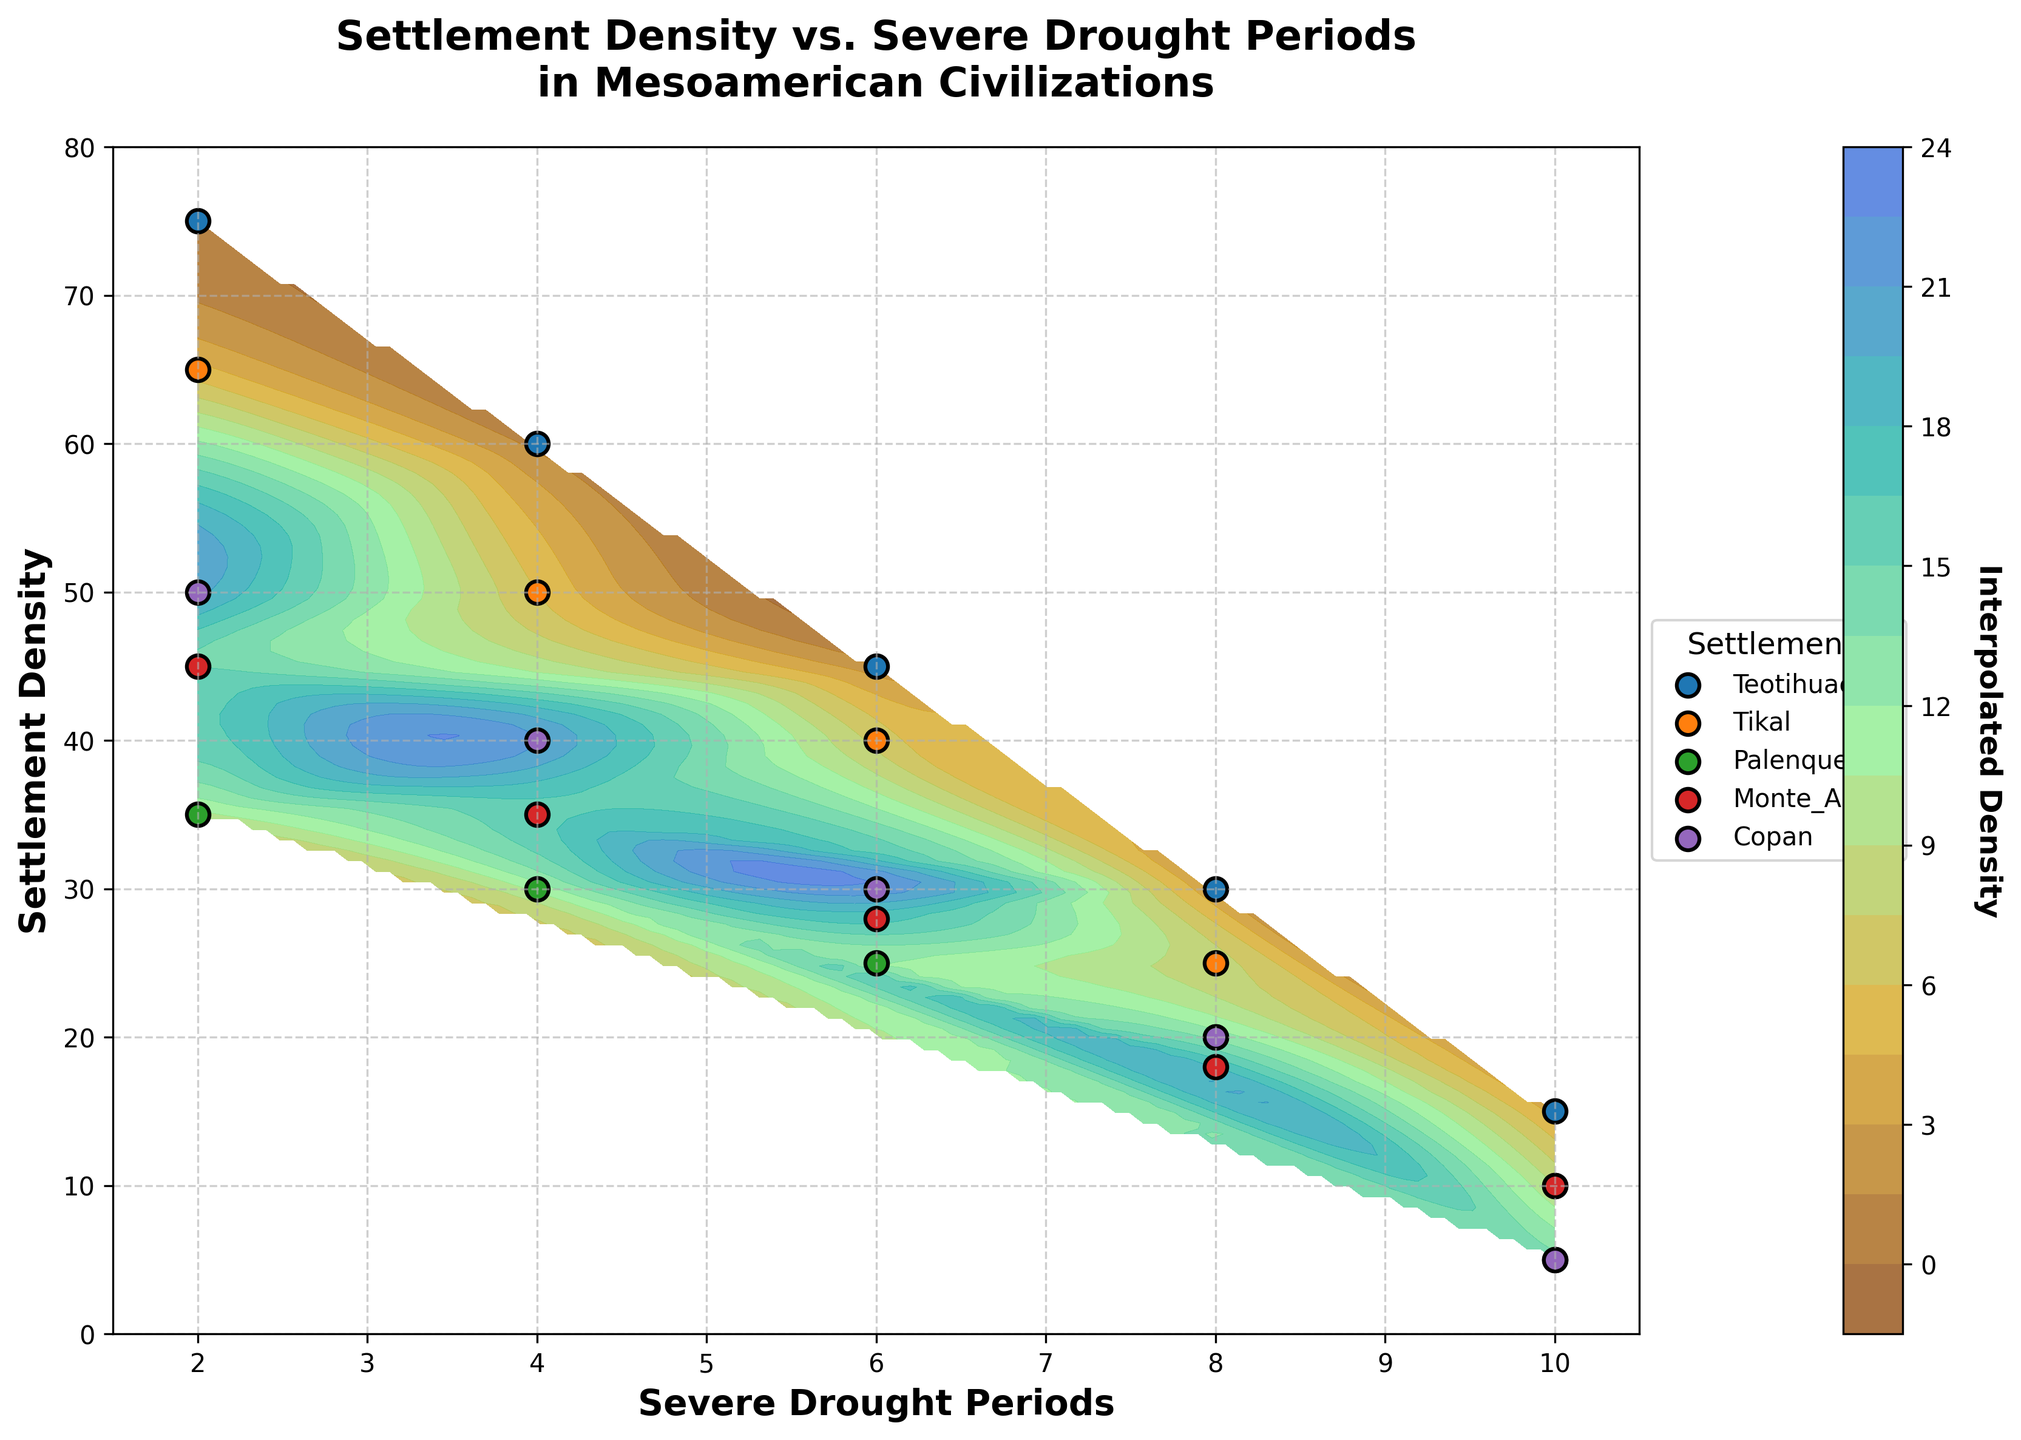what is the title of the figure? The title is usually displayed at the top of the figure. In this case, it reads "Settlement Density vs. Severe Drought Periods in Mesoamerican Civilizations," summarizing the content of the plot.
Answer: Settlement Density vs. Severe Drought Periods in Mesoamerican Civilizations What does the color bar represent? The color bar on the side of the plot usually indicates the scale of the interpolated density, which shows different gradations of Settlement Density based on the color map used.
Answer: Interpolated Density How many settlements are shown in the plot? The legend indicates the different settlements by using separate markers and labels. In this plot, each settlement has its own marker with its name next to it.
Answer: Five (Teotihuacan, Tikal, Palenque, Monte_Alban, Copan) Which settlement shows the highest initial density when the drought periods are 2? By looking at the points on the plot where the "Severe Drought Periods" is 2, we can compare the settlement densities. The highest point corresponds to Teotihuacan with 75.
Answer: Teotihuacan (75) At which level of severe drought periods do Monte_Alban and Copan have the same density? Find where the markers for Monte_Alban and Copan overlap on the x-axis for severe drought periods. This occurs at 10 severe drought periods where both have matching densities of 10.
Answer: 10 What is the trend of settlement density for Teotihuacan as severe drought periods increase? Observe the movement of Teotihuacan's points along the x-axis to see how density changes with increasing severe drought periods. Density decreases from 75 to 15 as severe drought periods rise from 2 to 10.
Answer: Decreases Compare the density of Tikal and Palenque for 6 severe drought periods. Which one is higher? Track the points for Tikal and Palenque when severe drought periods are 6. Tikal has a density of 40, while Palenque has 25.
Answer: Tikal (40) What's the average settlement density of Copan over the given severe drought periods? Add up the densities of Copan for all severe drought periods and divide by the number of periods: (50 + 40 + 30 + 20 + 5)/5.
Answer: 29 Which settlement has the steepest decline in density from 2 to 10 severe drought periods? Determine the change in density from 2 to 10 periods for each settlement and compare them. Teotihuacan drops from 75 to 15, which is the steepest drop of 60.
Answer: Teotihuacan 